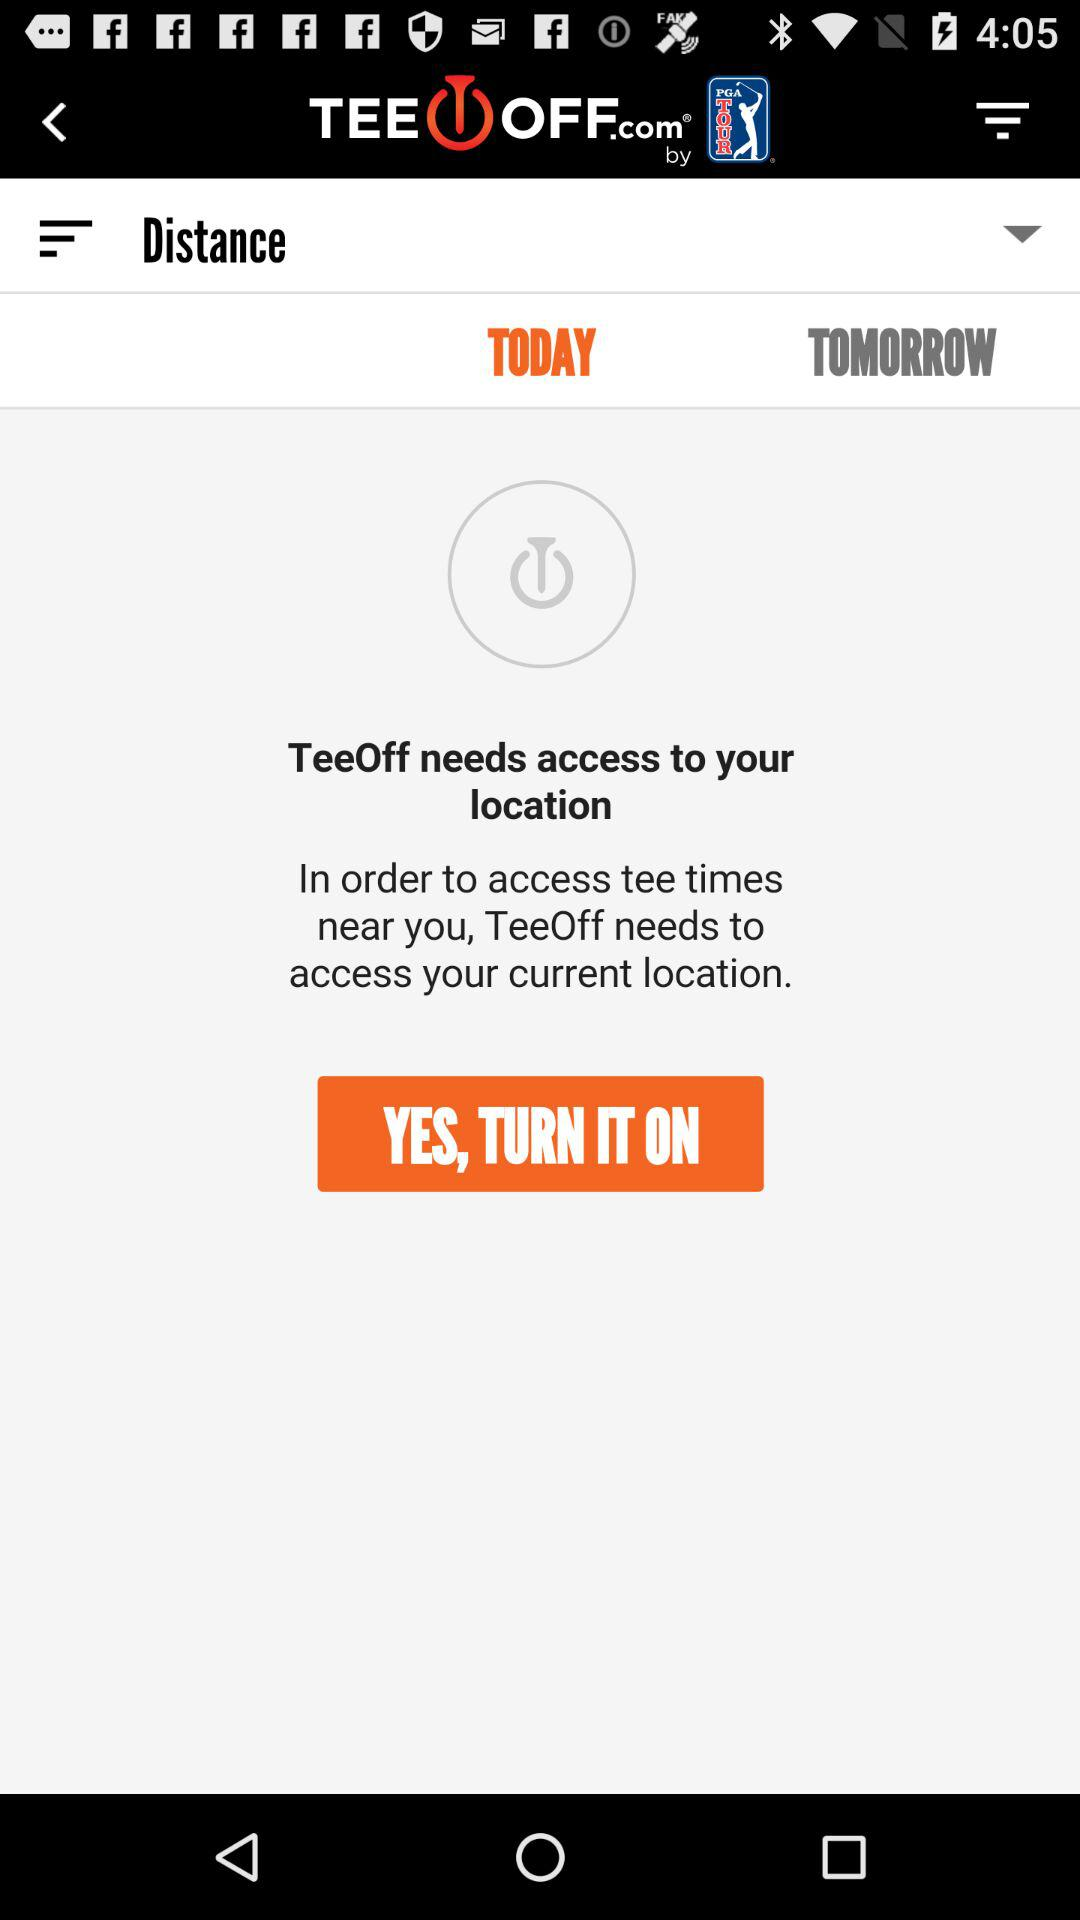What is the name of the application? The name of the application is "TeeOff". 